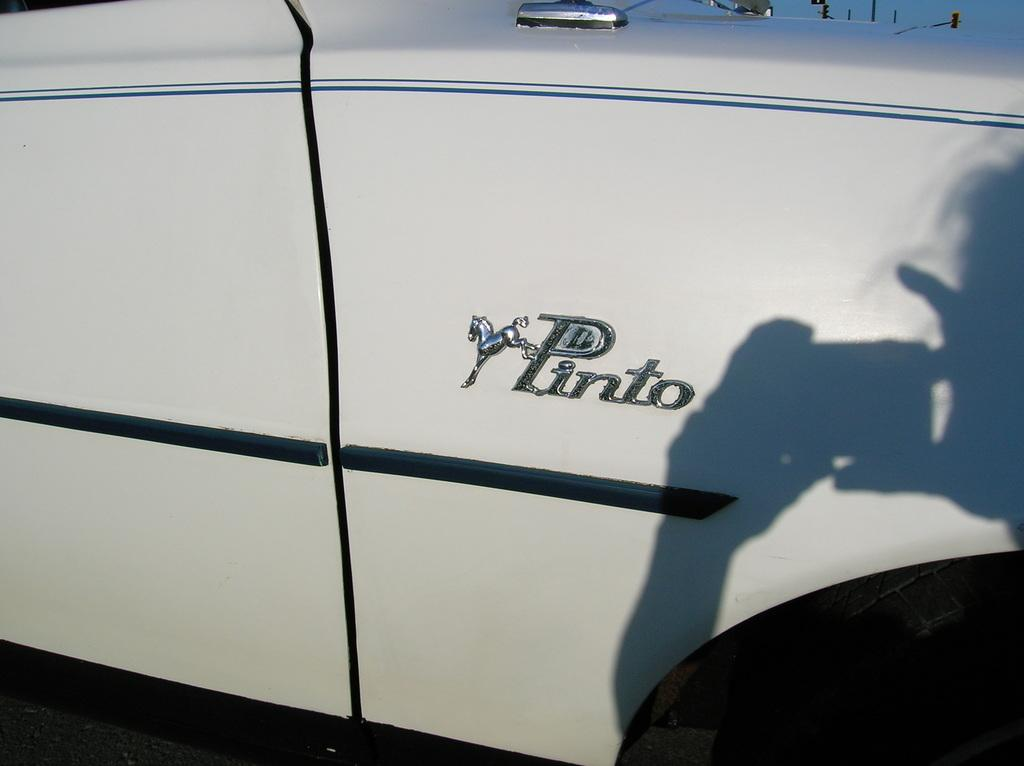What is the main subject in the image? There is a car in the center of the image. What type of bread is present in the image? There is no bread or loaf present in the image; it only features a car. 